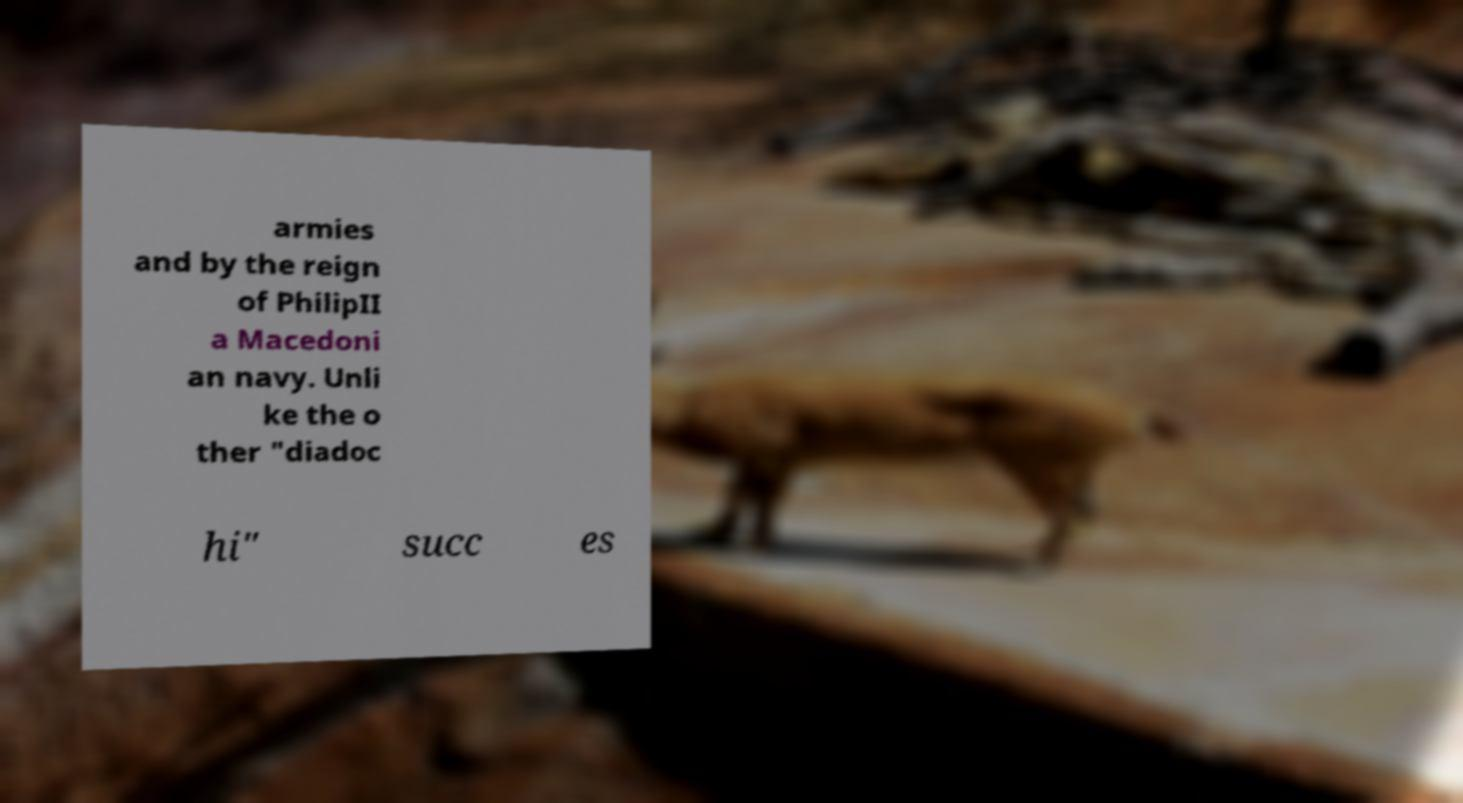Could you extract and type out the text from this image? armies and by the reign of PhilipII a Macedoni an navy. Unli ke the o ther "diadoc hi" succ es 